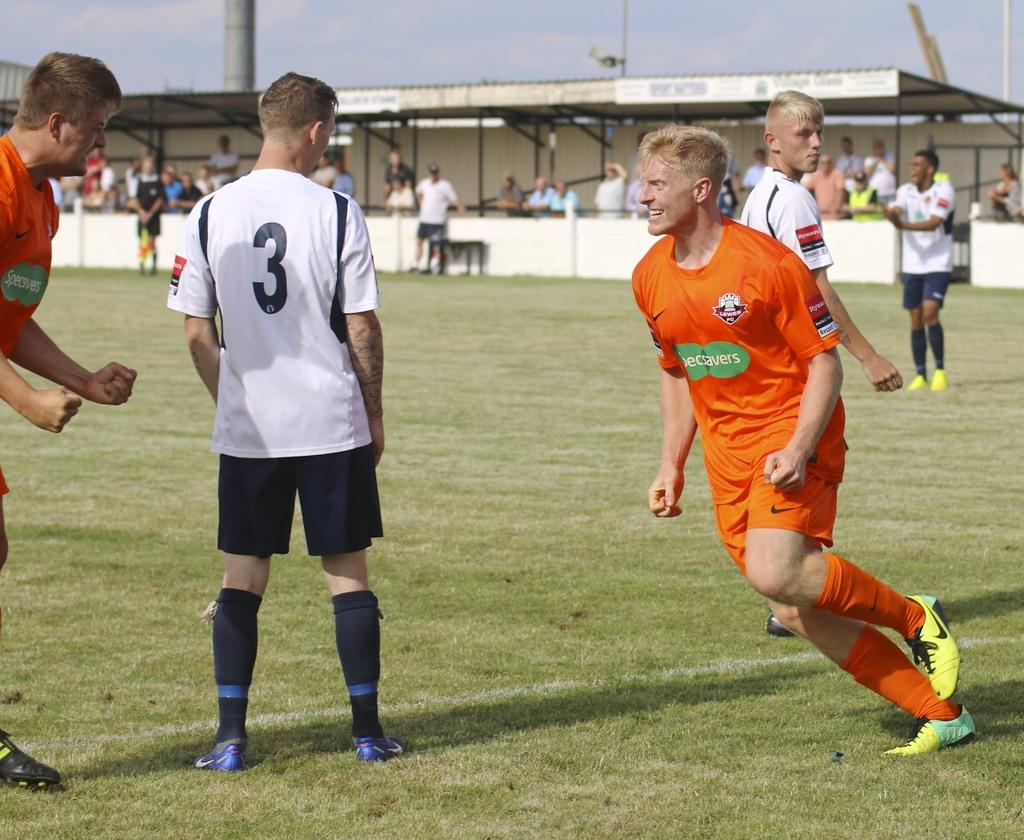Provide a one-sentence caption for the provided image. An athlete wearing a shirt with the number 3 stands on a field with his back to the game while players from the opposing team in orange smile. 